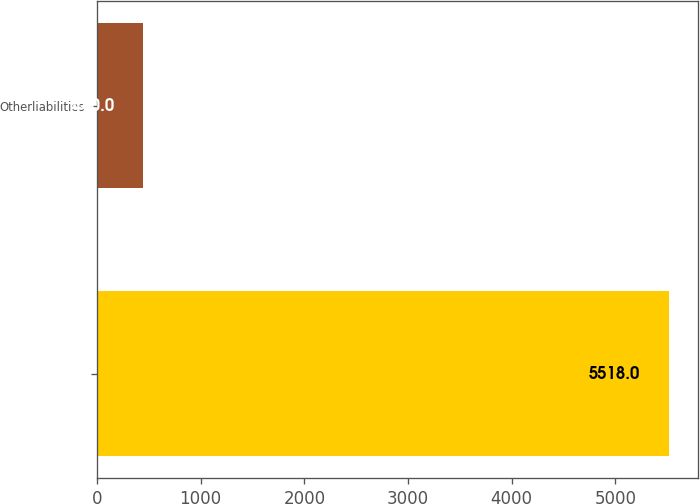Convert chart to OTSL. <chart><loc_0><loc_0><loc_500><loc_500><bar_chart><ecel><fcel>Otherliabilities<nl><fcel>5518<fcel>440<nl></chart> 